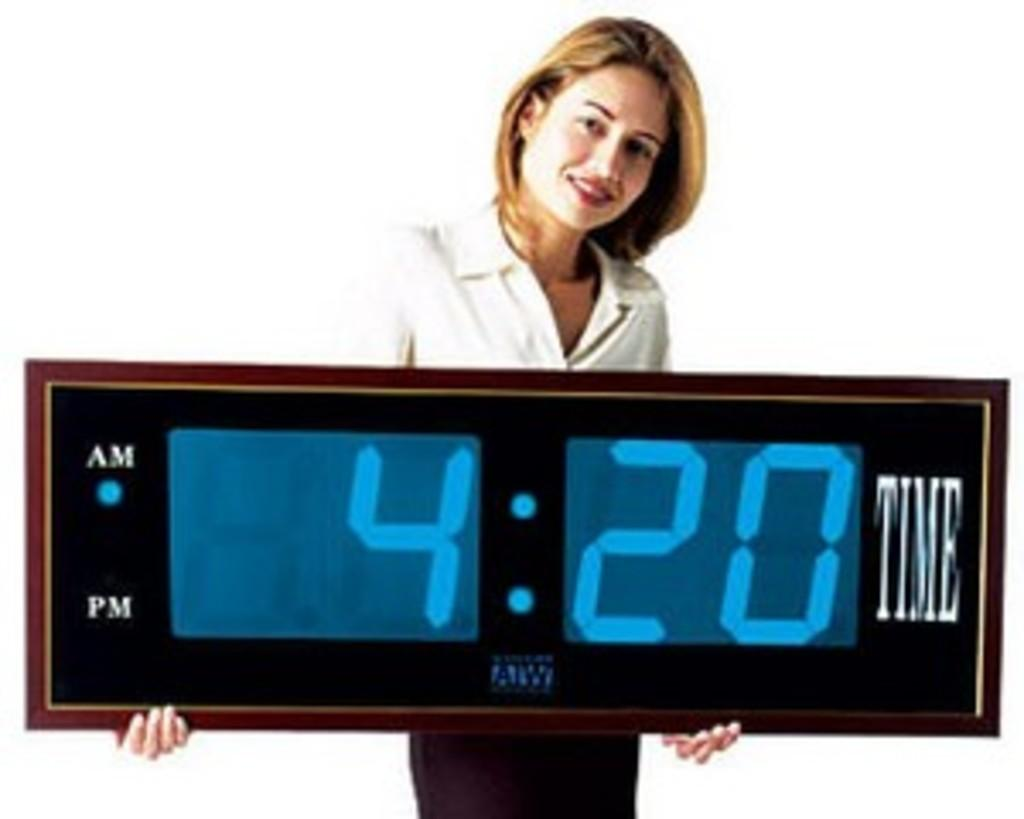<image>
Present a compact description of the photo's key features. A woman holds an oversize clock set to 4:20 am. 